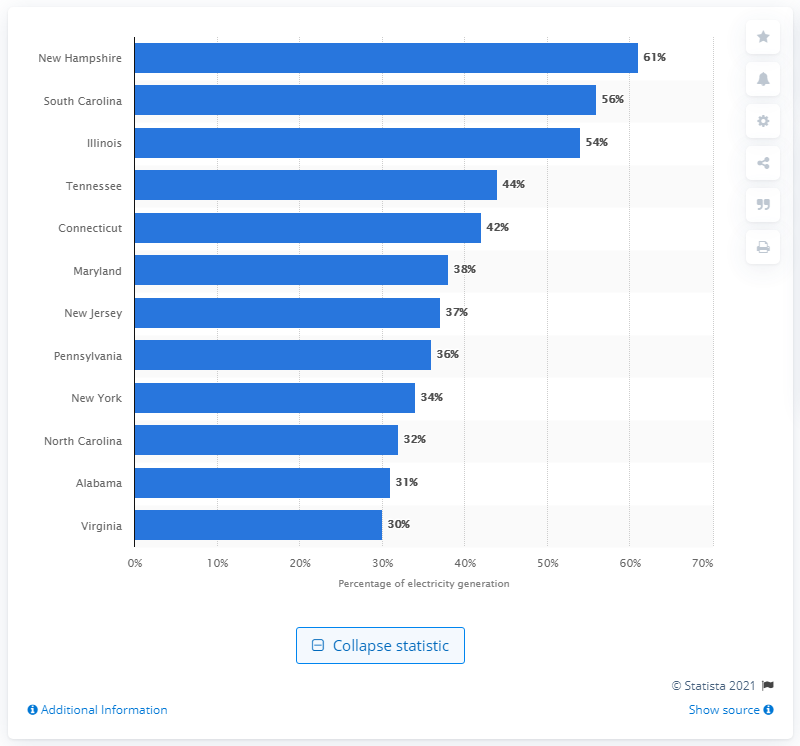Mention a couple of crucial points in this snapshot. According to data from 2019, New Hampshire had the highest share of nuclear power generation among all states in the United States. In 2019, South Carolina had the highest share of nuclear power generation among all states in the United States. 